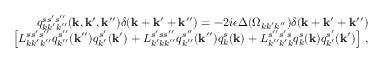Convert formula to latex. <formula><loc_0><loc_0><loc_500><loc_500>\begin{array} { r l r } & { q _ { k k ^ { \prime } k ^ { \prime \prime } } ^ { s s ^ { \prime } s ^ { \prime \prime } } ( { k } , { k } ^ { \prime } , { k } ^ { \prime \prime } ) \delta ( { k } + { k } ^ { \prime } + { k } ^ { \prime \prime } ) = - 2 i \epsilon \Delta ( \Omega _ { k k ^ { \prime } k ^ { \prime \prime } } ) \delta ( { k } + { k } ^ { \prime } + { k } ^ { \prime \prime } ) } \\ & { \left [ L _ { k k ^ { \prime } k ^ { \prime \prime } } ^ { s s ^ { \prime } s ^ { \prime \prime } } q _ { k ^ { \prime \prime } } ^ { s ^ { \prime \prime } } ( { k } ^ { \prime \prime } ) q _ { k ^ { \prime } } ^ { s ^ { \prime } } ( { k } ^ { \prime } ) + L _ { k ^ { \prime } k k ^ { \prime \prime } } ^ { s ^ { \prime } s s ^ { \prime \prime } } q _ { k ^ { \prime \prime } } ^ { s ^ { \prime \prime } } ( { k } ^ { \prime \prime } ) q _ { k } ^ { s } ( { k } ) + L _ { k ^ { \prime \prime } k ^ { \prime } k } ^ { s ^ { \prime \prime } s ^ { \prime } s } q _ { k } ^ { s } ( { k } ) q _ { k ^ { \prime } } ^ { s ^ { \prime } } ( { k } ^ { \prime } ) \right ] \, , } \end{array}</formula> 